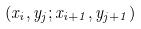Convert formula to latex. <formula><loc_0><loc_0><loc_500><loc_500>( x _ { i } , y _ { j } ; x _ { i + 1 } , y _ { j + 1 } )</formula> 